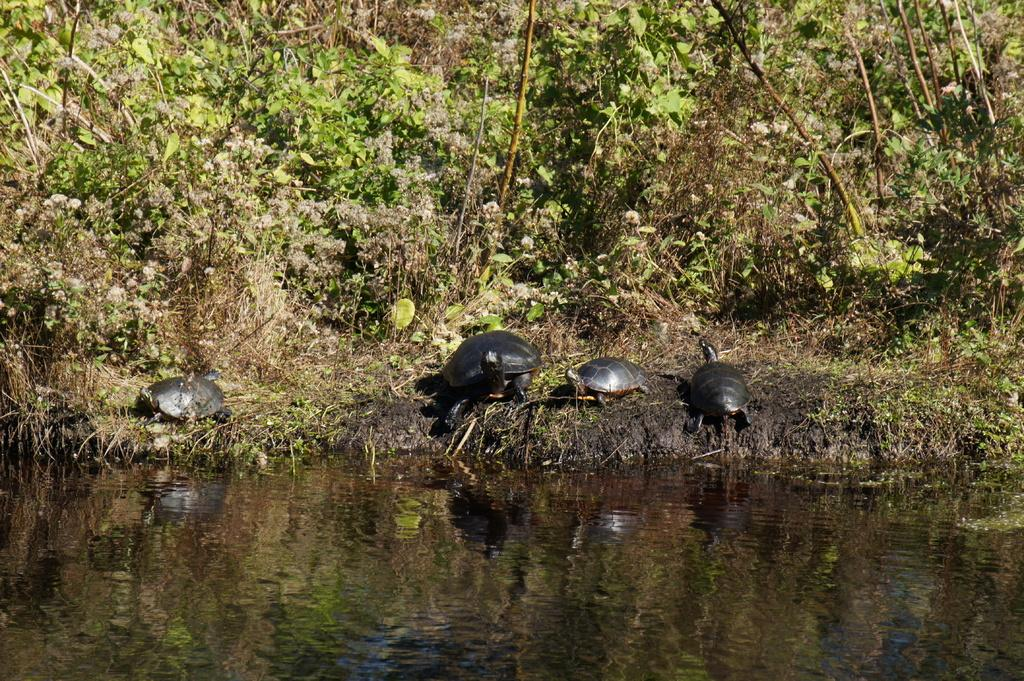What type of animals can be seen in the image? There are tortoises in the image. What type of vegetation is present in the image? There are trees and grass in the image. What natural element can be seen in the image? There is water visible in the image. Who is the uncle mentioned in the image? There is no mention of an uncle in the image. How many boats are visible in the image? There are no boats present in the image. 